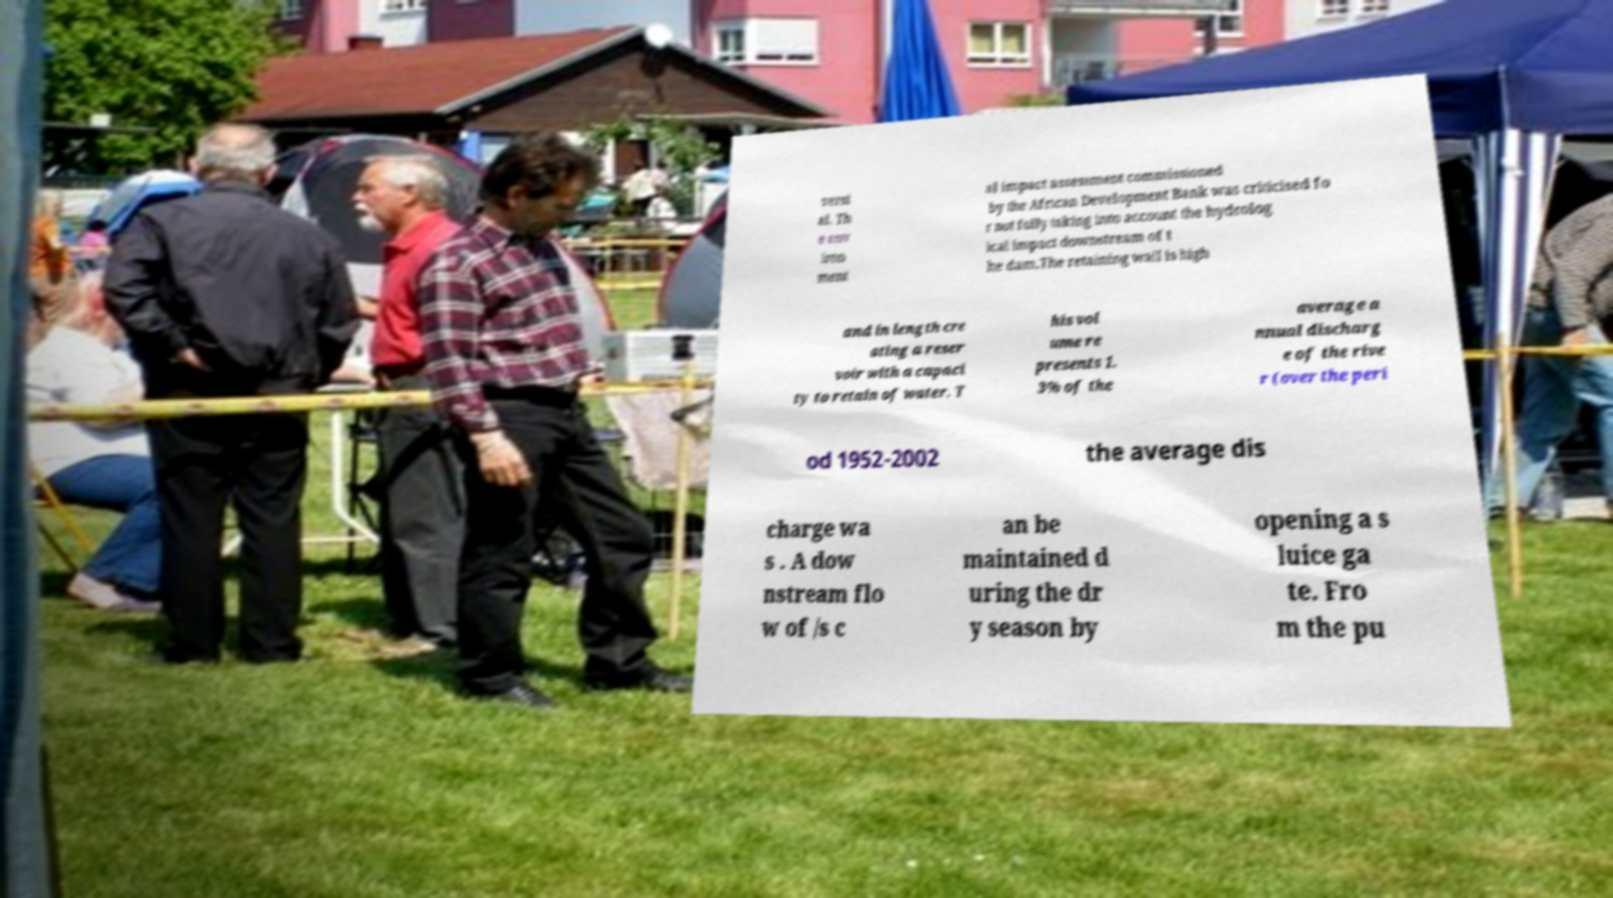What messages or text are displayed in this image? I need them in a readable, typed format. versi al. Th e env iron ment al impact assessment commissioned by the African Development Bank was criticised fo r not fully taking into account the hydrolog ical impact downstream of t he dam.The retaining wall is high and in length cre ating a reser voir with a capaci ty to retain of water. T his vol ume re presents 1. 3% of the average a nnual discharg e of the rive r (over the peri od 1952-2002 the average dis charge wa s . A dow nstream flo w of /s c an be maintained d uring the dr y season by opening a s luice ga te. Fro m the pu 